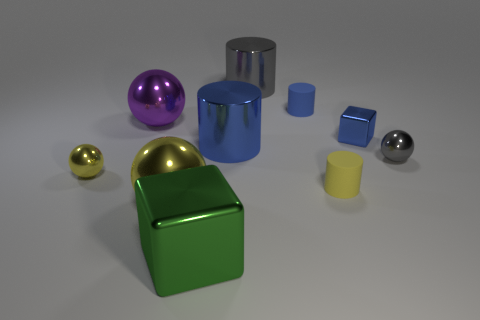Can you describe the lighting in the scene? The scene has soft, diffused lighting with what appears to be a single light source from the top, casting gentle shadows beneath the objects and highlighting their glossy surfaces. 